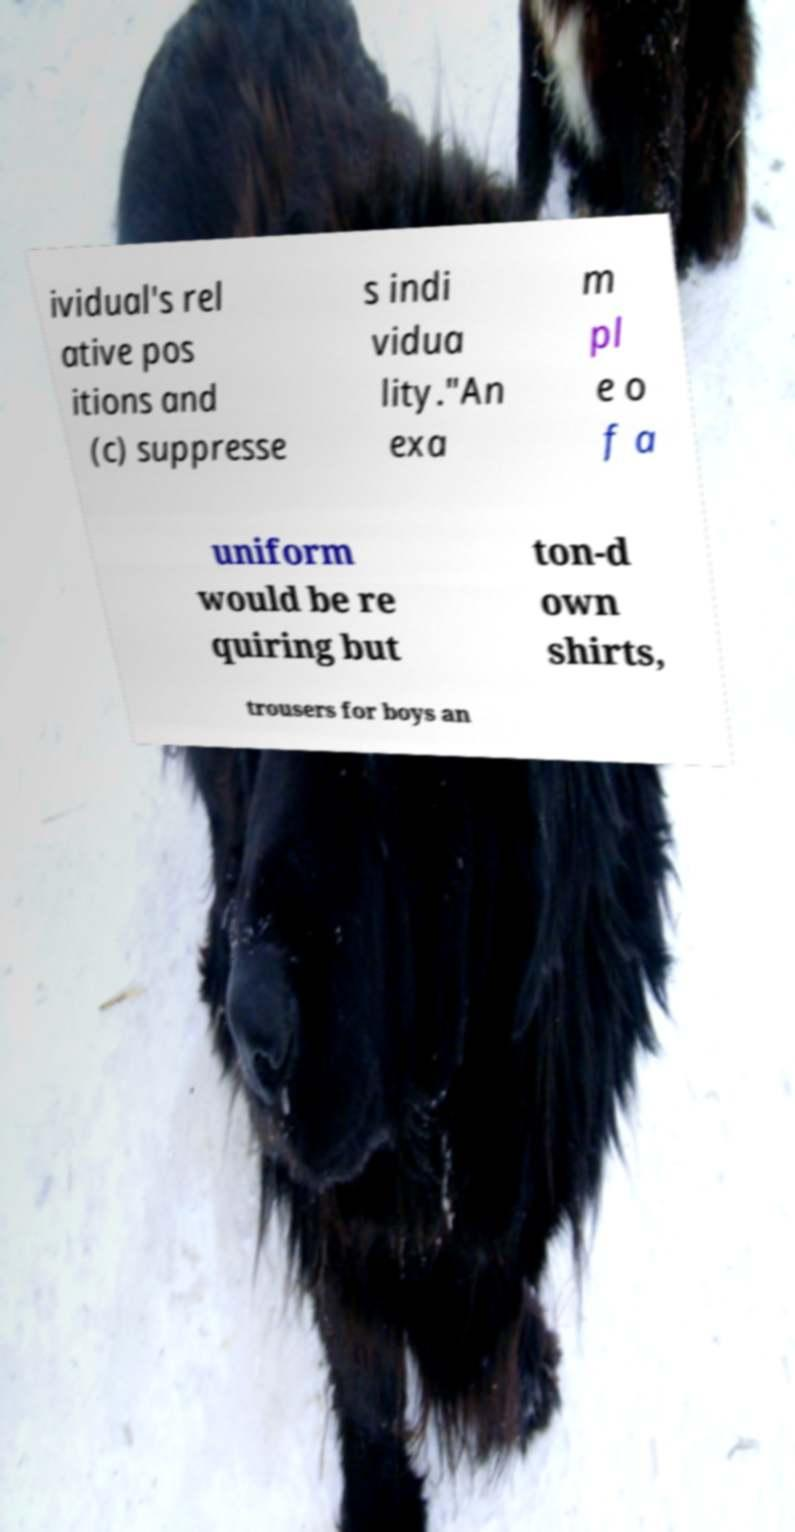Could you assist in decoding the text presented in this image and type it out clearly? ividual's rel ative pos itions and (c) suppresse s indi vidua lity."An exa m pl e o f a uniform would be re quiring but ton-d own shirts, trousers for boys an 